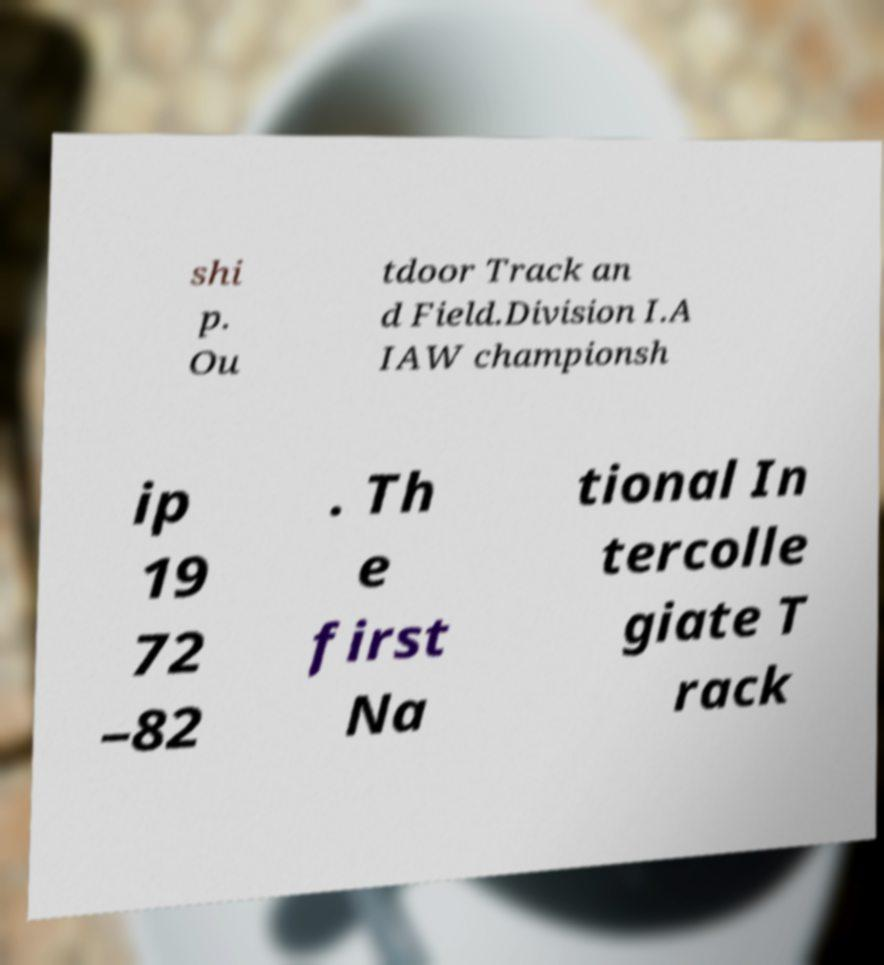Could you extract and type out the text from this image? shi p. Ou tdoor Track an d Field.Division I.A IAW championsh ip 19 72 –82 . Th e first Na tional In tercolle giate T rack 